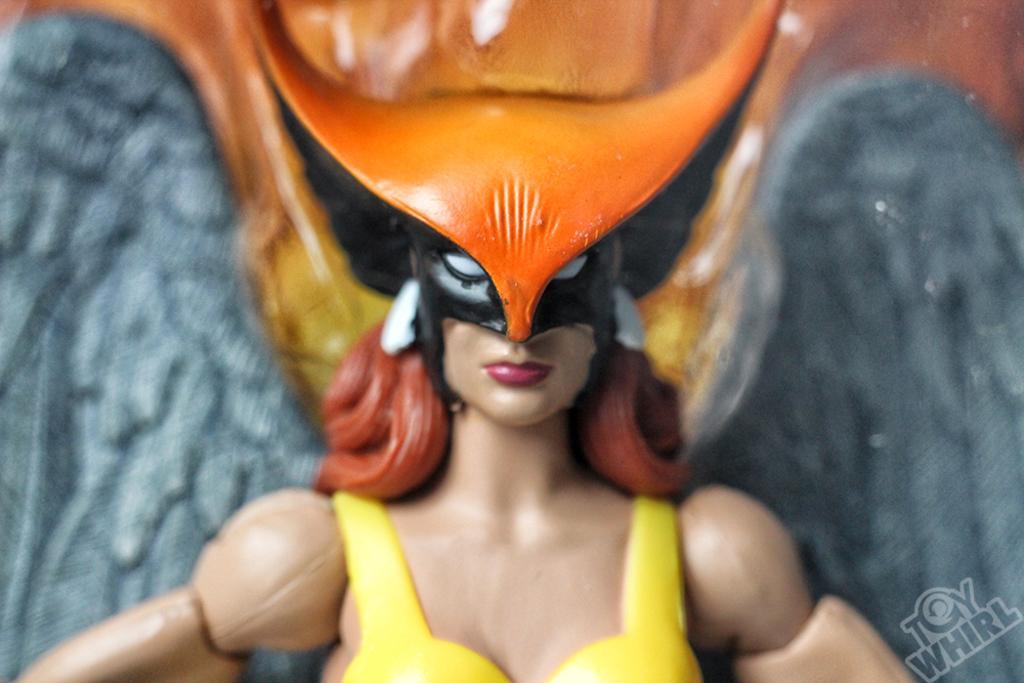Please provide a concise description of this image. This is a zoomed in picture. In the center we can see the sculpture of a woman wearing a mask. In the background we can see some other objects. In the bottom right corner we can see the watermark on the image. 